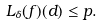<formula> <loc_0><loc_0><loc_500><loc_500>L _ { \delta } ( f ) ( d ) \leq p .</formula> 